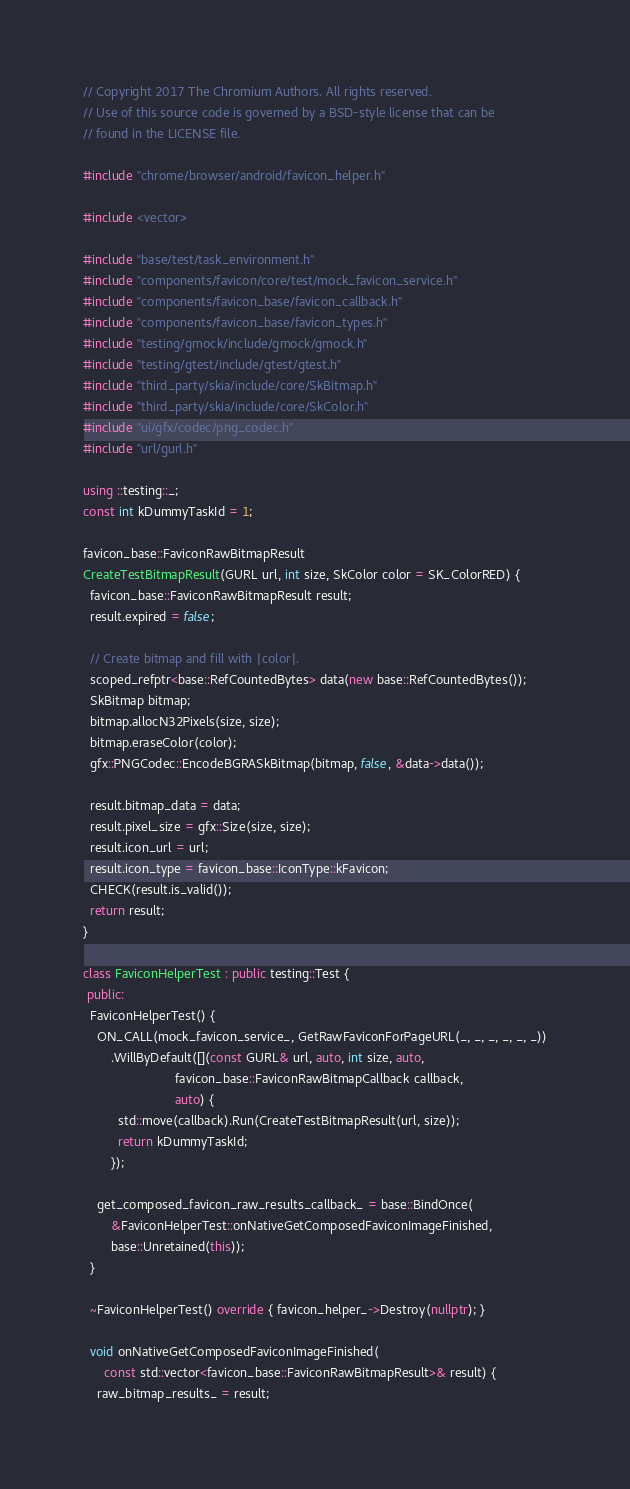<code> <loc_0><loc_0><loc_500><loc_500><_C++_>// Copyright 2017 The Chromium Authors. All rights reserved.
// Use of this source code is governed by a BSD-style license that can be
// found in the LICENSE file.

#include "chrome/browser/android/favicon_helper.h"

#include <vector>

#include "base/test/task_environment.h"
#include "components/favicon/core/test/mock_favicon_service.h"
#include "components/favicon_base/favicon_callback.h"
#include "components/favicon_base/favicon_types.h"
#include "testing/gmock/include/gmock/gmock.h"
#include "testing/gtest/include/gtest/gtest.h"
#include "third_party/skia/include/core/SkBitmap.h"
#include "third_party/skia/include/core/SkColor.h"
#include "ui/gfx/codec/png_codec.h"
#include "url/gurl.h"

using ::testing::_;
const int kDummyTaskId = 1;

favicon_base::FaviconRawBitmapResult
CreateTestBitmapResult(GURL url, int size, SkColor color = SK_ColorRED) {
  favicon_base::FaviconRawBitmapResult result;
  result.expired = false;

  // Create bitmap and fill with |color|.
  scoped_refptr<base::RefCountedBytes> data(new base::RefCountedBytes());
  SkBitmap bitmap;
  bitmap.allocN32Pixels(size, size);
  bitmap.eraseColor(color);
  gfx::PNGCodec::EncodeBGRASkBitmap(bitmap, false, &data->data());

  result.bitmap_data = data;
  result.pixel_size = gfx::Size(size, size);
  result.icon_url = url;
  result.icon_type = favicon_base::IconType::kFavicon;
  CHECK(result.is_valid());
  return result;
}

class FaviconHelperTest : public testing::Test {
 public:
  FaviconHelperTest() {
    ON_CALL(mock_favicon_service_, GetRawFaviconForPageURL(_, _, _, _, _, _))
        .WillByDefault([](const GURL& url, auto, int size, auto,
                          favicon_base::FaviconRawBitmapCallback callback,
                          auto) {
          std::move(callback).Run(CreateTestBitmapResult(url, size));
          return kDummyTaskId;
        });

    get_composed_favicon_raw_results_callback_ = base::BindOnce(
        &FaviconHelperTest::onNativeGetComposedFaviconImageFinished,
        base::Unretained(this));
  }

  ~FaviconHelperTest() override { favicon_helper_->Destroy(nullptr); }

  void onNativeGetComposedFaviconImageFinished(
      const std::vector<favicon_base::FaviconRawBitmapResult>& result) {
    raw_bitmap_results_ = result;</code> 